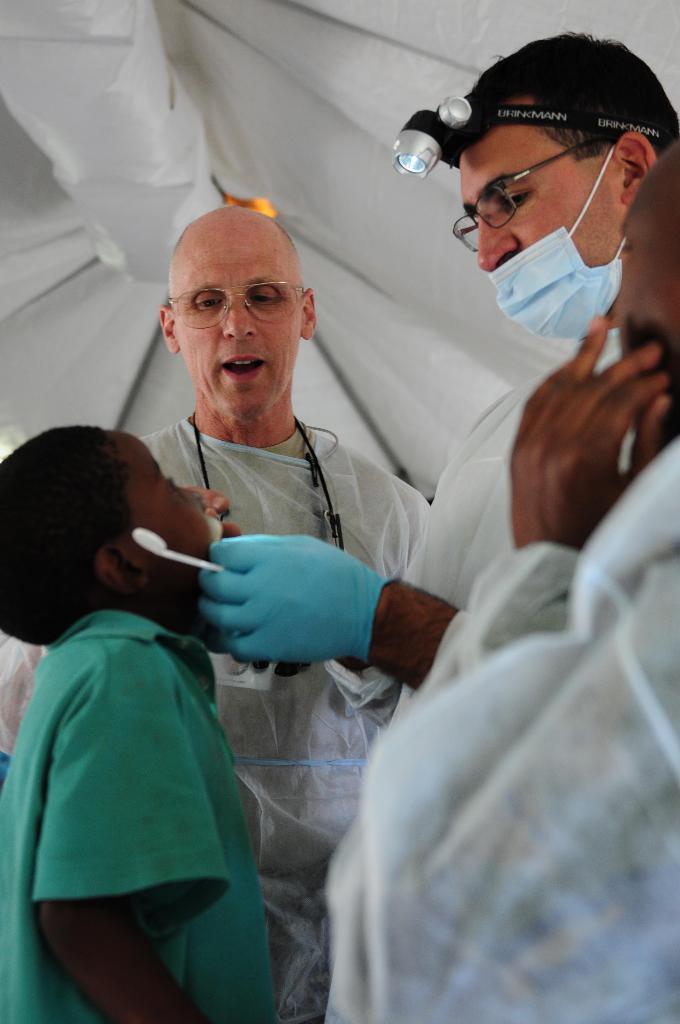Describe this image in one or two sentences. Here we can see four persons. They have spectacles. There is a white background. 